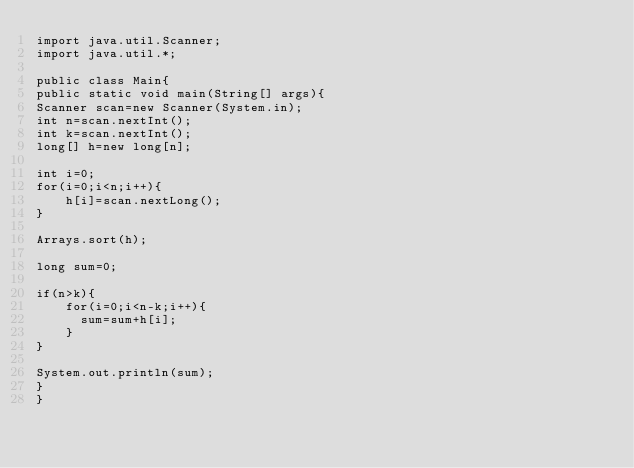Convert code to text. <code><loc_0><loc_0><loc_500><loc_500><_Java_>import java.util.Scanner;
import java.util.*;

public class Main{
public static void main(String[] args){
Scanner scan=new Scanner(System.in);
int n=scan.nextInt();
int k=scan.nextInt();  
long[] h=new long[n];

int i=0;  
for(i=0;i<n;i++){
    h[i]=scan.nextLong();
}
  
Arrays.sort(h);
  
long sum=0;

if(n>k){
    for(i=0;i<n-k;i++){
      sum=sum+h[i];
    }
}

System.out.println(sum);
}
}
</code> 